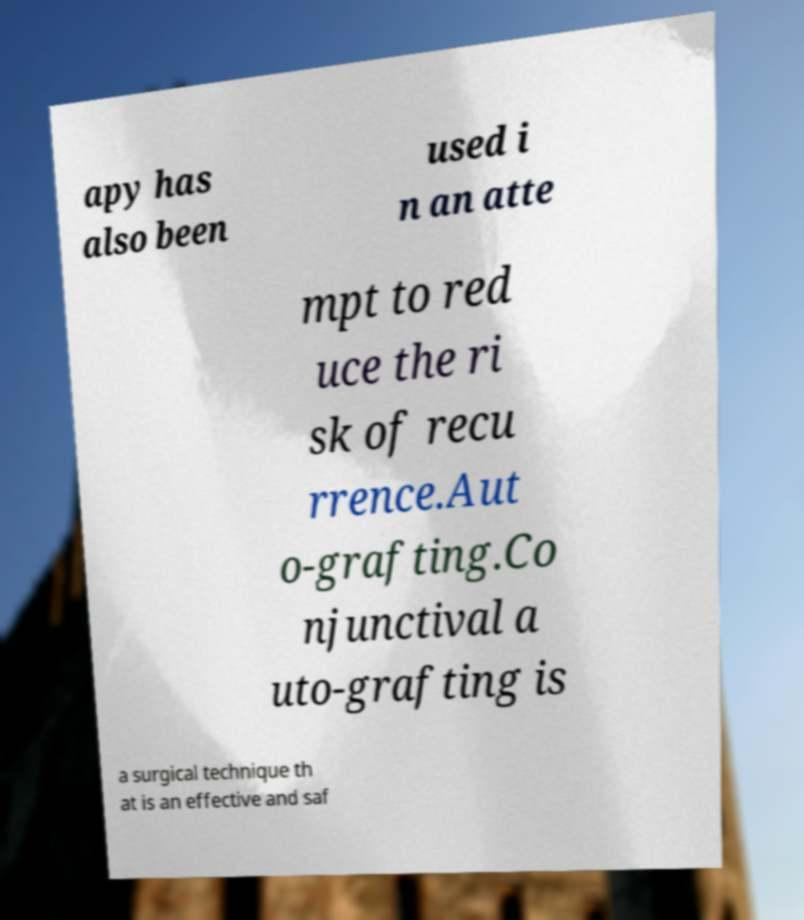Please identify and transcribe the text found in this image. apy has also been used i n an atte mpt to red uce the ri sk of recu rrence.Aut o-grafting.Co njunctival a uto-grafting is a surgical technique th at is an effective and saf 